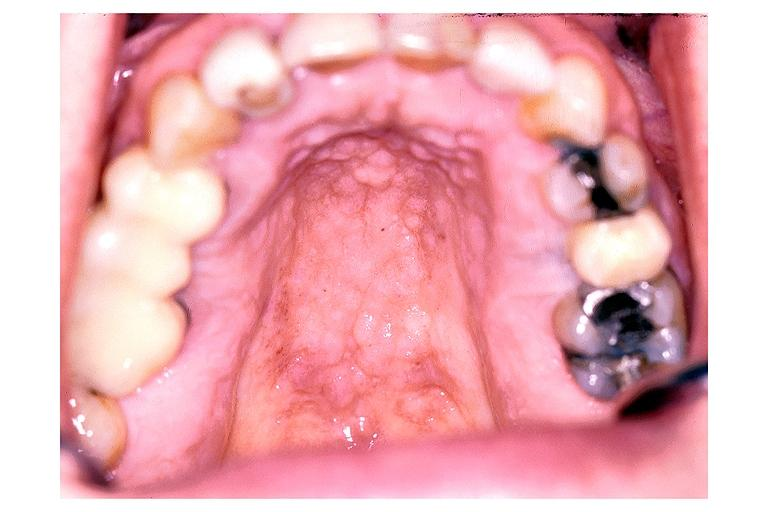where is this?
Answer the question using a single word or phrase. Oral 